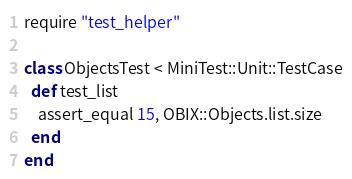Convert code to text. <code><loc_0><loc_0><loc_500><loc_500><_Ruby_>require "test_helper"

class ObjectsTest < MiniTest::Unit::TestCase
  def test_list
    assert_equal 15, OBIX::Objects.list.size
  end
end
</code> 